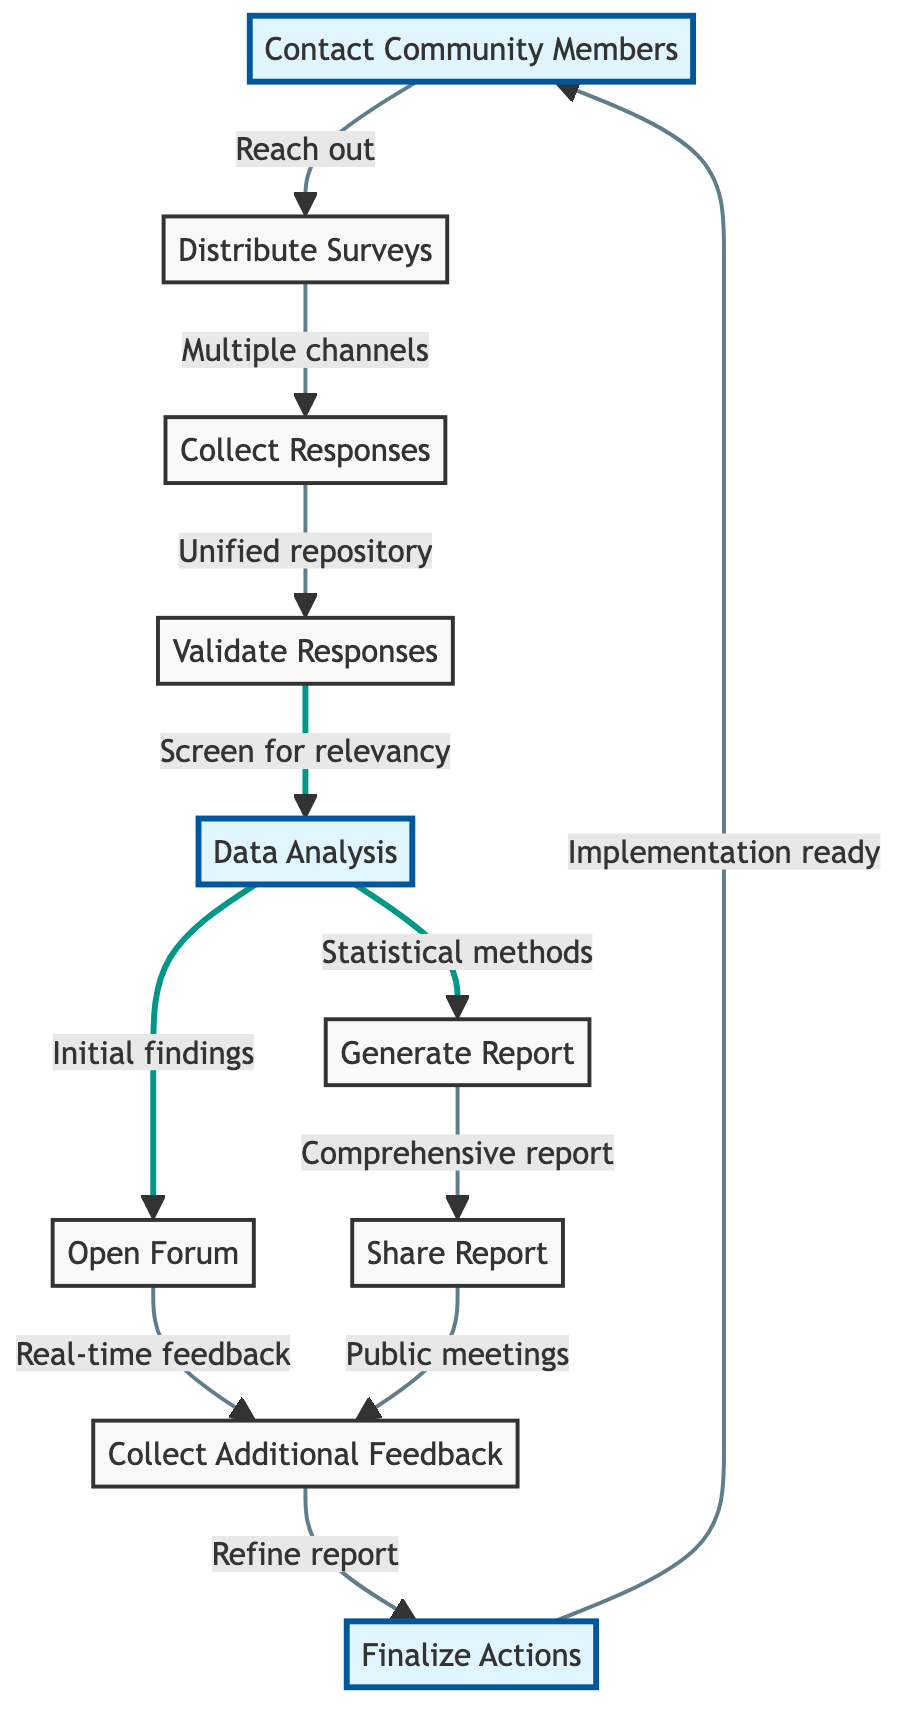What is the first step in the community feedback collection process? The first step in the flow chart is "Contact Community Members." This is indicated as the starting point from which the process begins.
Answer: Contact Community Members How many nodes are in the flow chart? There are a total of ten nodes displayed in the flow chart, each representing a specific step in the process.
Answer: 10 What follows after "Collect Responses"? The step that follows "Collect Responses" is "Validate Responses," as indicated by the arrow leading to that node in the diagram.
Answer: Validate Responses Which two nodes stem from "Data Analysis"? The two nodes stemming from "Data Analysis" are "Generate Report" and "Open Forum," as shown by the two output connections from that node.
Answer: Generate Report, Open Forum What is the purpose of the "Open Forum" step? The purpose of the "Open Forum" step is to hold discussions regarding initial findings and to gather real-time feedback for deeper insights, as described in the diagram.
Answer: Discuss initial findings How does "Share Report" connect to "Collect Additional Feedback"? "Share Report" connects to "Collect Additional Feedback" because both have an arrow leading to the same next step, indicating that sharing the report prompts further feedback collection.
Answer: They are directly connected What is the final step indicated in the flow chart? The final step indicated in the flow chart is "Finalize Actions," which is where actionable plans are developed based on the collected feedback.
Answer: Finalize Actions Which step emphasizes screening for relevancy? The step that emphasizes screening for relevancy is "Validate Responses," as it specifically mentions ensuring the responses are relevant to local issues in Eden-Monaro.
Answer: Validate Responses What is indicated by the arrows in the diagram? The arrows in the diagram indicate the flow and sequence of the steps involved in the community feedback collection and analysis process, showing which step leads to the next.
Answer: The flow and sequence of steps 